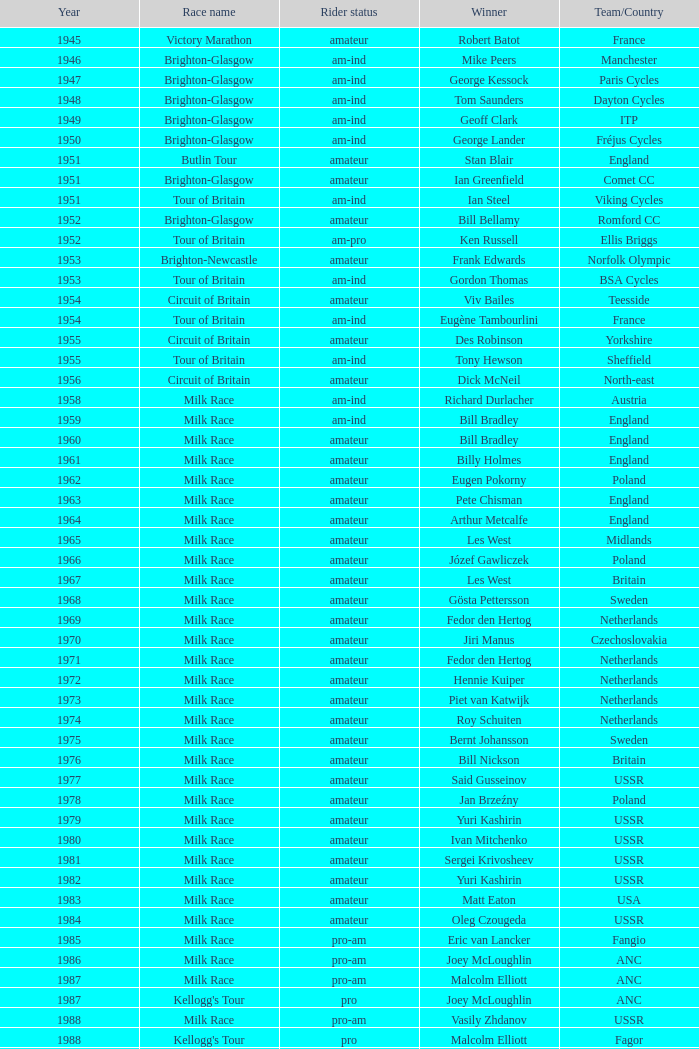Who was the winner in 1973 with an amateur rider status? Piet van Katwijk. 